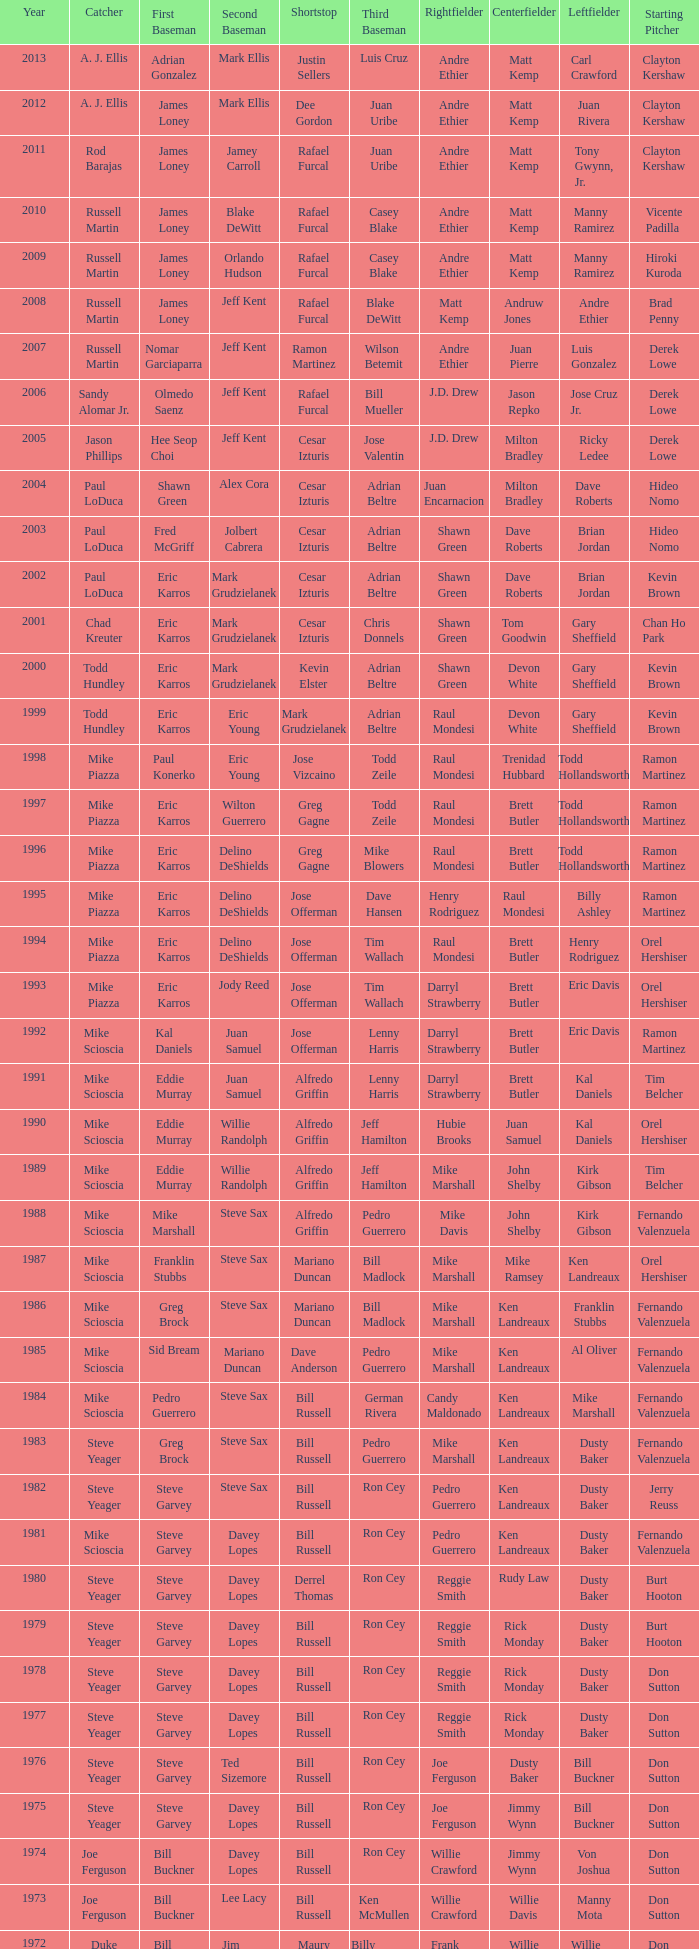Who played 2nd base when nomar garciaparra was at 1st base? Jeff Kent. 